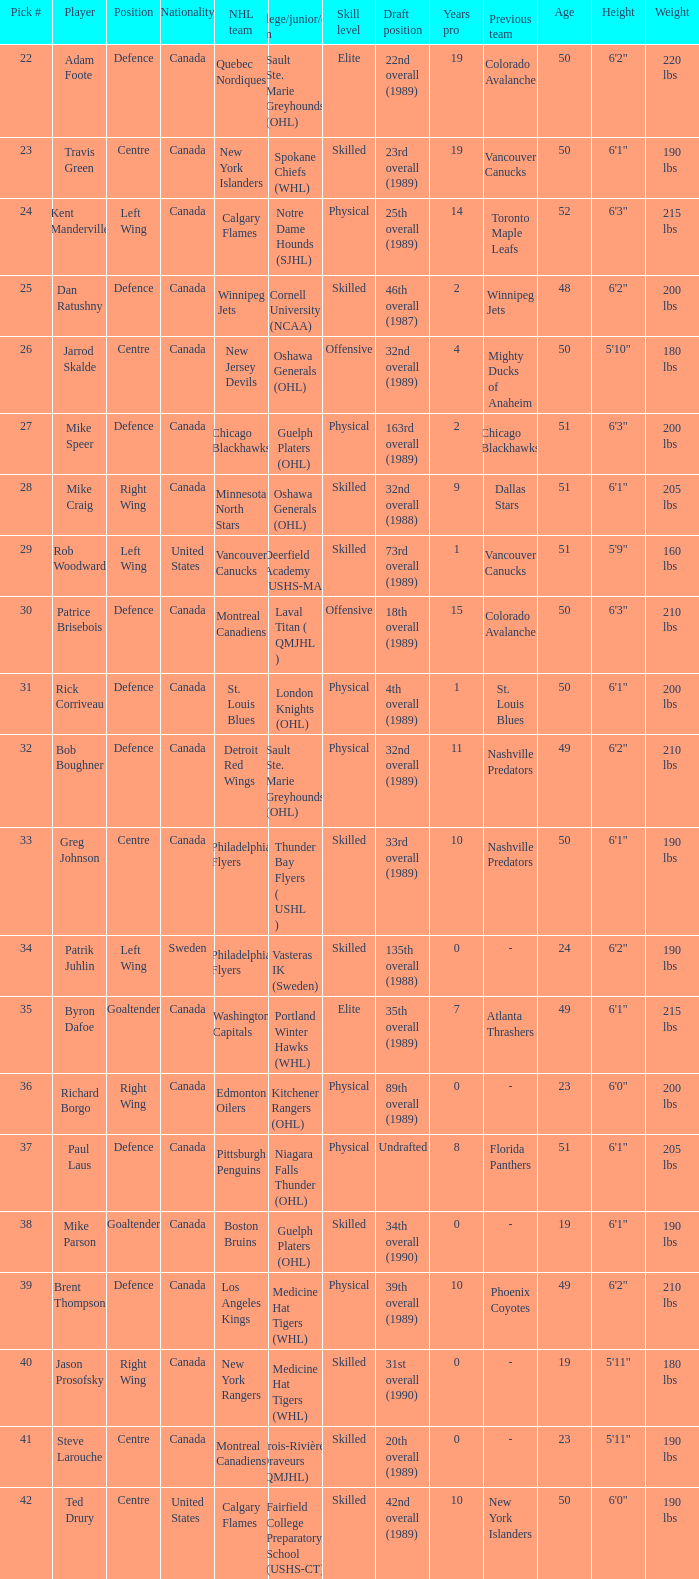What is the nationality of the player picked to go to Washington Capitals? Canada. 